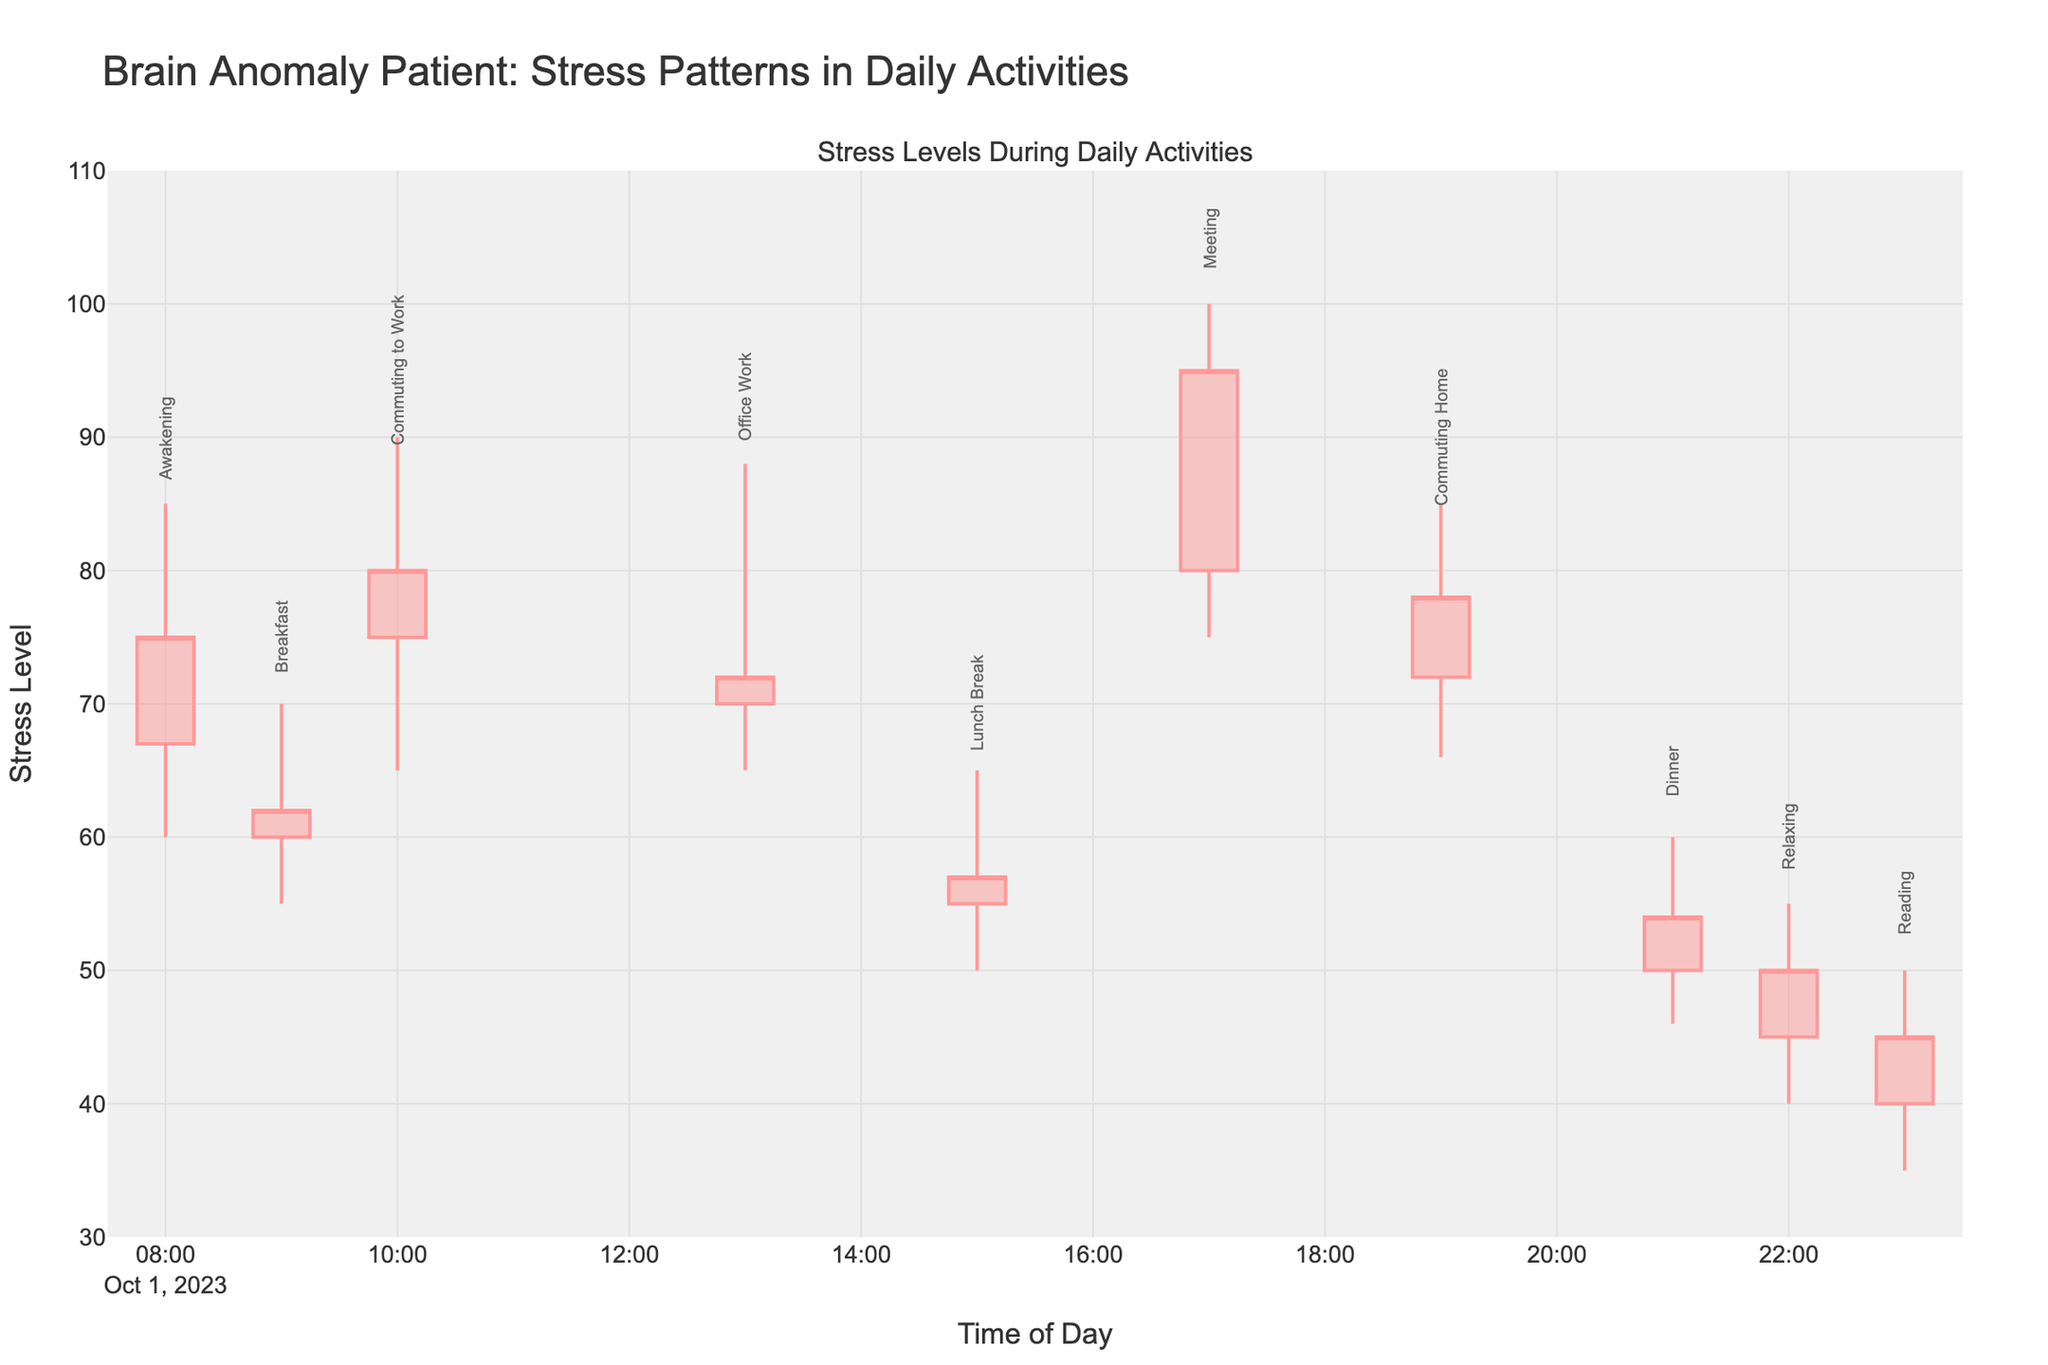What's the title of the figure? The title is found at the top of the figure, summarizing the overall theme of the plot.
Answer: Brain Anomaly Patient: Stress Patterns in Daily Activities What is the lowest stress level recorded during Office Work? The lowest stress level can be found in the "low" value for the Office Work activity.
Answer: 65 At what time did the activity "Reading" start? The time at which any activity starts is indicated by the timestamp on the x-axis.
Answer: 23:00 Which activity had the highest peak stress level, and what was that level? The highest peak stress level can be found by looking at the highest "high" values among all activities. "Meeting" had the highest peak stress level.
Answer: Meeting, 100 What is the difference between the high and low stress levels during Breakfast? The difference is calculated by subtracting the low value from the high value for the Breakfast activity.
Answer: 15 During which activity was the stress level at its lowest overall? The lowest overall stress level is the smallest "low" value among all activities.
Answer: Reading How does the opening stress level of Awakening compare to the closing stress level of Commuting to Work? To compare, note the opening value of Awakening and the closing value of Commuting to Work, then find the difference.
Answer: Awakening: 67, Commuting to Work: 80 Which activities had a closing stress level lower than their opening stress level? Identify the activities where the "close" value is less than the "open" value. These activities are Breakfast, Office Work, Lunch Break, Dinner, Relaxing, and Reading.
Answer: Breakfast, Office Work, Lunch Break, Dinner, Relaxing, Reading What was the average of the high stress levels for Lunch Break and Dinner? To find the average, add the high values of Lunch Break and Dinner, then divide by 2.
Answer: (65 + 60) / 2 = 62.5 Which activity showed the most significant increase in stress level from open to close? Calculate the difference between the opening and closing stress levels for each activity, and identify the one with the largest increase.
Answer: Meeting, (95 - 80) = 15 